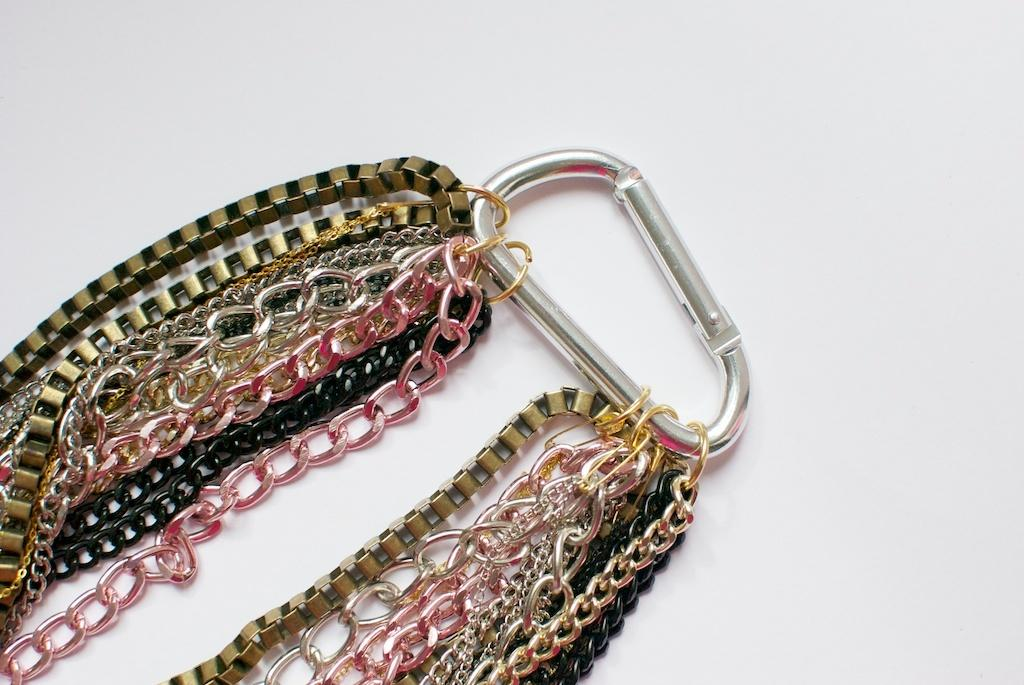What is the main subject of the image? The main subject of the image is a ring. What is the color of the background in the image? The ring is on a white background. What additional features can be seen on the ring? The ring contains some chains. How many yams are being harvested on the farm in the image? There is no farm or yams present in the image; it features a ring on a white background with chains. 